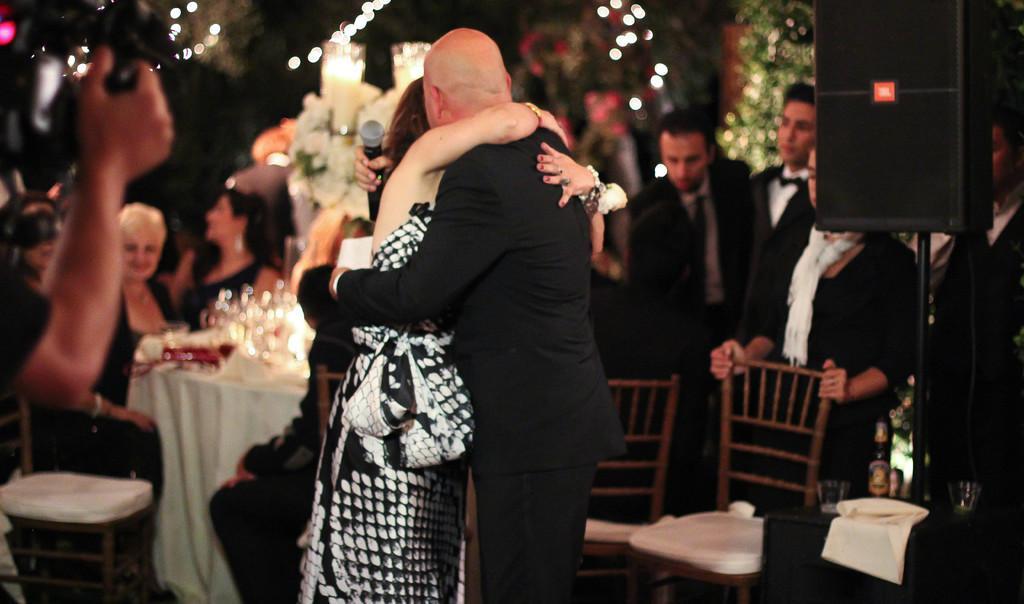Could you give a brief overview of what you see in this image? In this image I can see people where few of them are standing and rest all are sitting. I can also see few chairs and tables. Here I can see he is holding a mic and hear a hand of a person with a camera. 